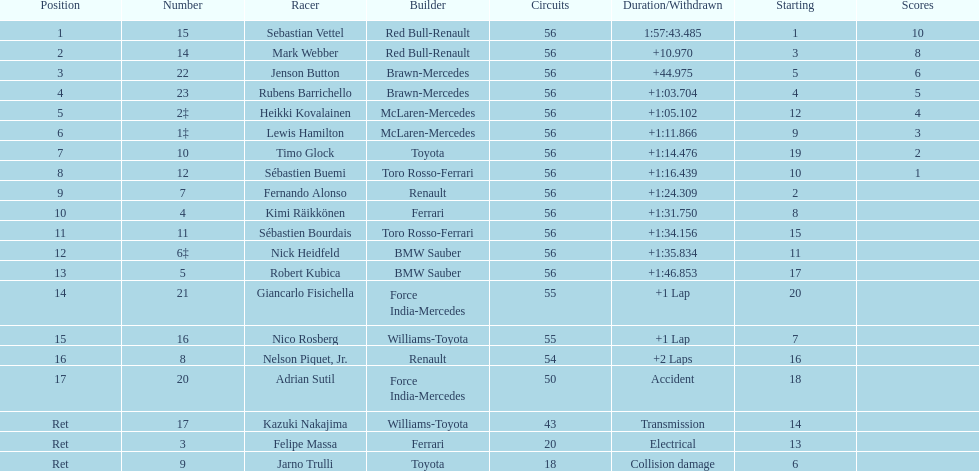What is the name of a driver that ferrari was not a constructor for? Sebastian Vettel. 